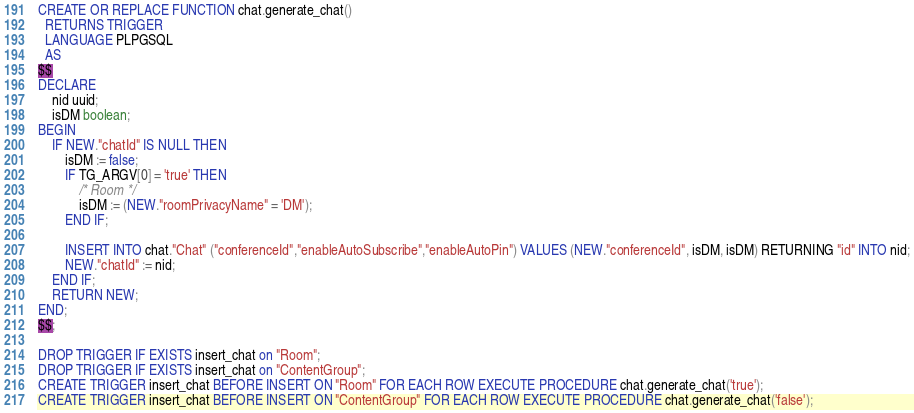<code> <loc_0><loc_0><loc_500><loc_500><_SQL_>CREATE OR REPLACE FUNCTION chat.generate_chat()
  RETURNS TRIGGER
  LANGUAGE PLPGSQL
  AS
$$
DECLARE
    nid uuid;
    isDM boolean;
BEGIN
    IF NEW."chatId" IS NULL THEN
        isDM := false;
        IF TG_ARGV[0] = 'true' THEN
            /* Room */
            isDM := (NEW."roomPrivacyName" = 'DM');
        END IF;

	    INSERT INTO chat."Chat" ("conferenceId","enableAutoSubscribe","enableAutoPin") VALUES (NEW."conferenceId", isDM, isDM) RETURNING "id" INTO nid;
        NEW."chatId" := nid;
    END IF;
	RETURN NEW;
END;
$$;

DROP TRIGGER IF EXISTS insert_chat on "Room";
DROP TRIGGER IF EXISTS insert_chat on "ContentGroup";
CREATE TRIGGER insert_chat BEFORE INSERT ON "Room" FOR EACH ROW EXECUTE PROCEDURE chat.generate_chat('true');
CREATE TRIGGER insert_chat BEFORE INSERT ON "ContentGroup" FOR EACH ROW EXECUTE PROCEDURE chat.generate_chat('false');
</code> 